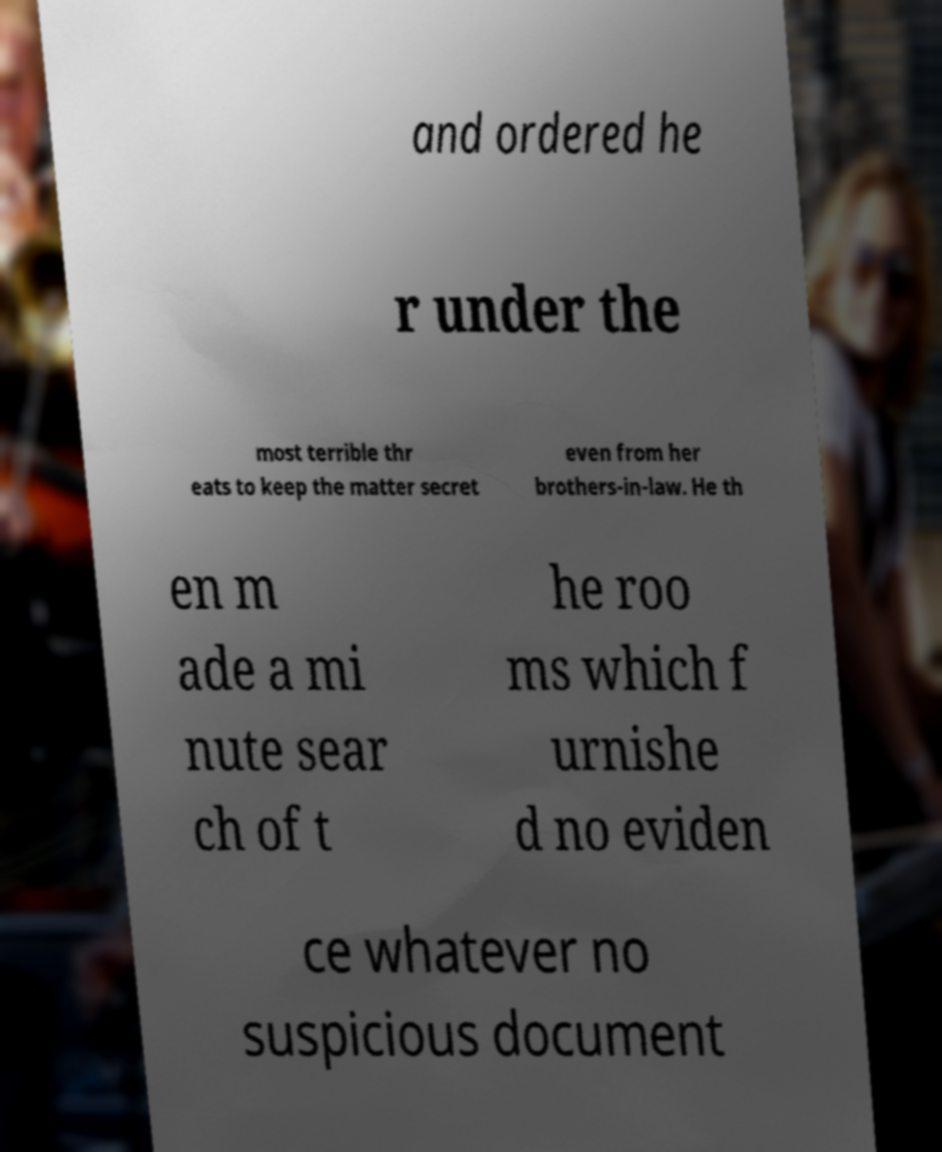Please identify and transcribe the text found in this image. and ordered he r under the most terrible thr eats to keep the matter secret even from her brothers-in-law. He th en m ade a mi nute sear ch of t he roo ms which f urnishe d no eviden ce whatever no suspicious document 